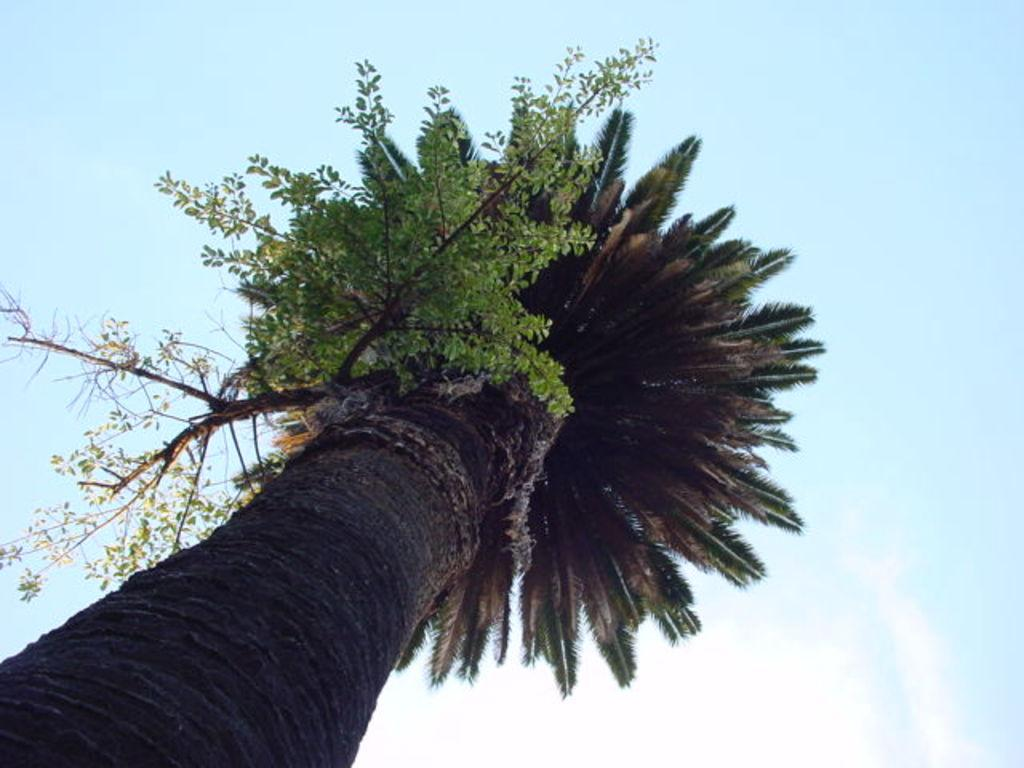What is the main subject of the image? The main subject of the image is a tree with another tree on it. What can be seen in the background of the image? There is sky visible in the background of the image. What type of food is being served on the tree in the image? There is no food present in the image; it features a tree with another tree on it. How much honey can be seen dripping from the branches of the tree in the image? There is no honey present in the image; it only features trees. 